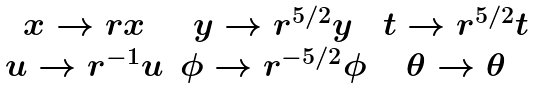Convert formula to latex. <formula><loc_0><loc_0><loc_500><loc_500>\begin{array} { c c c } x \to r x & y \to r ^ { 5 / 2 } y & t \to r ^ { 5 / 2 } t \\ u \to r ^ { - 1 } u & \phi \to r ^ { - 5 / 2 } \phi & \theta \to \theta \end{array}</formula> 